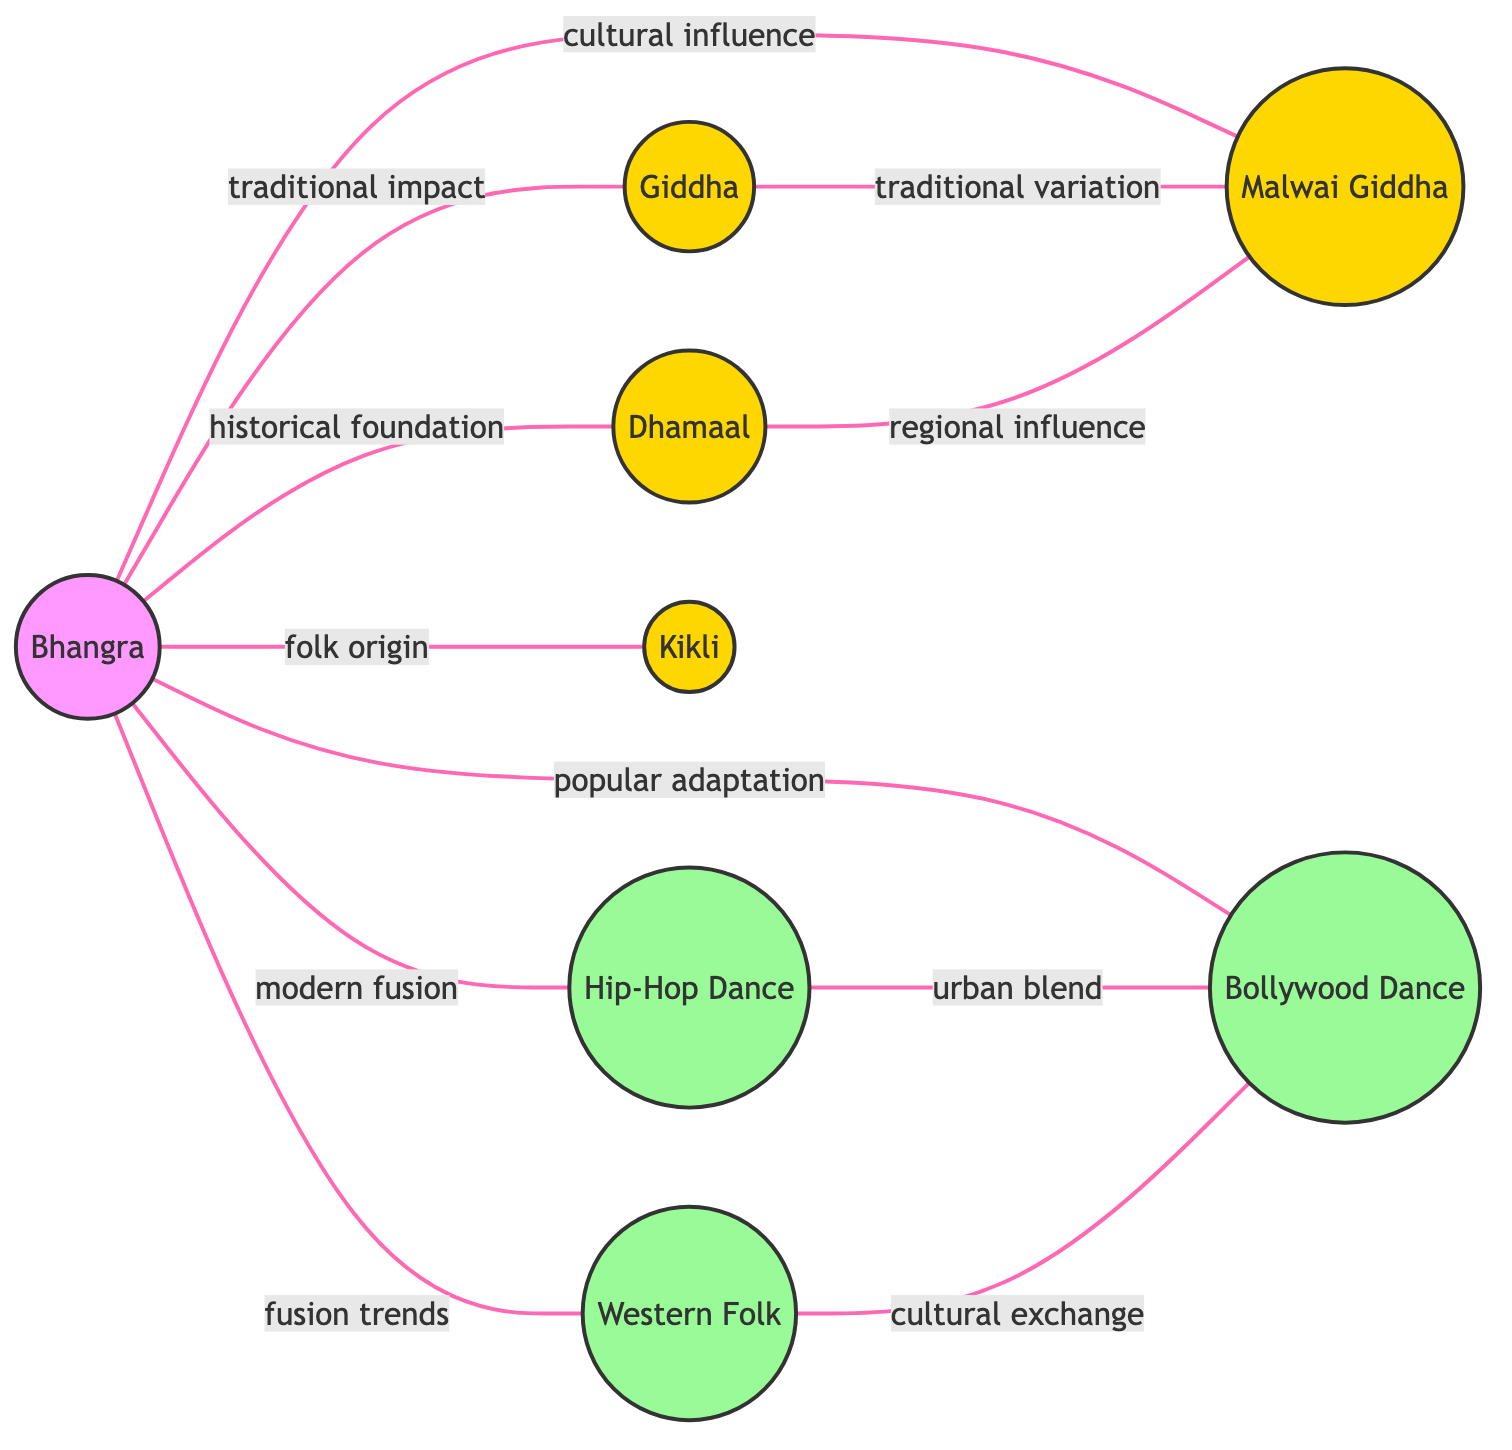What is the total number of nodes in the diagram? The nodes in the diagram are Bhangra, Giddha, Malwai Giddha, Dhamaal, Hip-Hop Dance, Bollywood Dance, Kikli, and Western Folk, which total to eight distinct nodes.
Answer: 8 What is the relationship between Bhangra and Giddha? In the diagram, the connection between Bhangra and Giddha is labeled as "traditional impact," indicating that Bhangra has a traditionally impactful relationship with Giddha.
Answer: traditional impact Which two styles are connected by "urban blend"? The "urban blend" relationship connects Hip-Hop Dance and Bollywood Dance in the diagram, indicating a fusion or blending of these dance styles.
Answer: Hip-Hop Dance and Bollywood Dance How many edges does Bhangra have? Bhangra is connected to seven other styles (Giddha, Malwai Giddha, Dhamaal, Hip-Hop Dance, Bollywood Dance, Kikli, and Western Folk), constituting seven edges.
Answer: 7 What type of relationship connects Dhamaal and Malwai Giddha? The relationship between Dhamaal and Malwai Giddha is categorized as "regional influence." This suggests that Dhamaal has influenced the characteristics of Malwai Giddha in a regional context.
Answer: regional influence Which dance style exhibits a traditional variation of Giddha? Malwai Giddha is indicated as a traditional variation of Giddha according to the relationship identified in the diagram.
Answer: Malwai Giddha How many modern dance styles are represented in the diagram? The modern dance styles present are Hip-Hop Dance, Bollywood Dance, and Western Folk, leading to a total of three modern styles represented in the diagram.
Answer: 3 What is the common relationship between Western Folk and Bollywood Dance? The relationship between Western Folk and Bollywood Dance is described as "cultural exchange," implying that these styles influence each other through cultural interactions.
Answer: cultural exchange Which folk dance serves as an origin for Bhangra? Kikli is noted as the folk origin for Bhangra in the diagram, indicating a foundational relationship where Kikli has influenced the development of Bhangra.
Answer: Kikli 